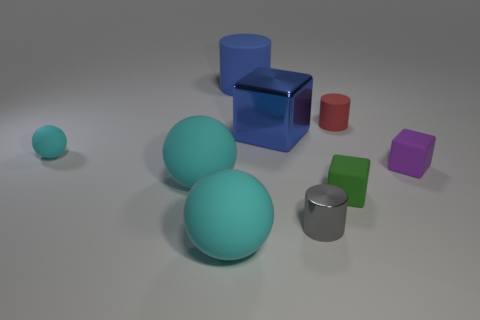There is a big matte object that is the same color as the large metal object; what is its shape?
Ensure brevity in your answer.  Cylinder. What number of other things are made of the same material as the red thing?
Ensure brevity in your answer.  6. There is a cyan thing that is the same size as the red cylinder; what is it made of?
Your answer should be compact. Rubber. Is there a large shiny cylinder of the same color as the tiny rubber cylinder?
Offer a terse response. No. There is a tiny object that is to the left of the tiny green object and behind the purple rubber cube; what is its shape?
Provide a succinct answer. Sphere. How many large cyan balls are made of the same material as the tiny red cylinder?
Ensure brevity in your answer.  2. Are there fewer big matte objects in front of the shiny block than matte cubes that are to the left of the tiny red object?
Give a very brief answer. No. There is a tiny cylinder that is behind the ball that is behind the rubber block that is behind the green thing; what is its material?
Provide a short and direct response. Rubber. How big is the cylinder that is on the left side of the tiny red matte cylinder and right of the big blue matte cylinder?
Your response must be concise. Small. What number of spheres are small green matte things or gray things?
Make the answer very short. 0. 